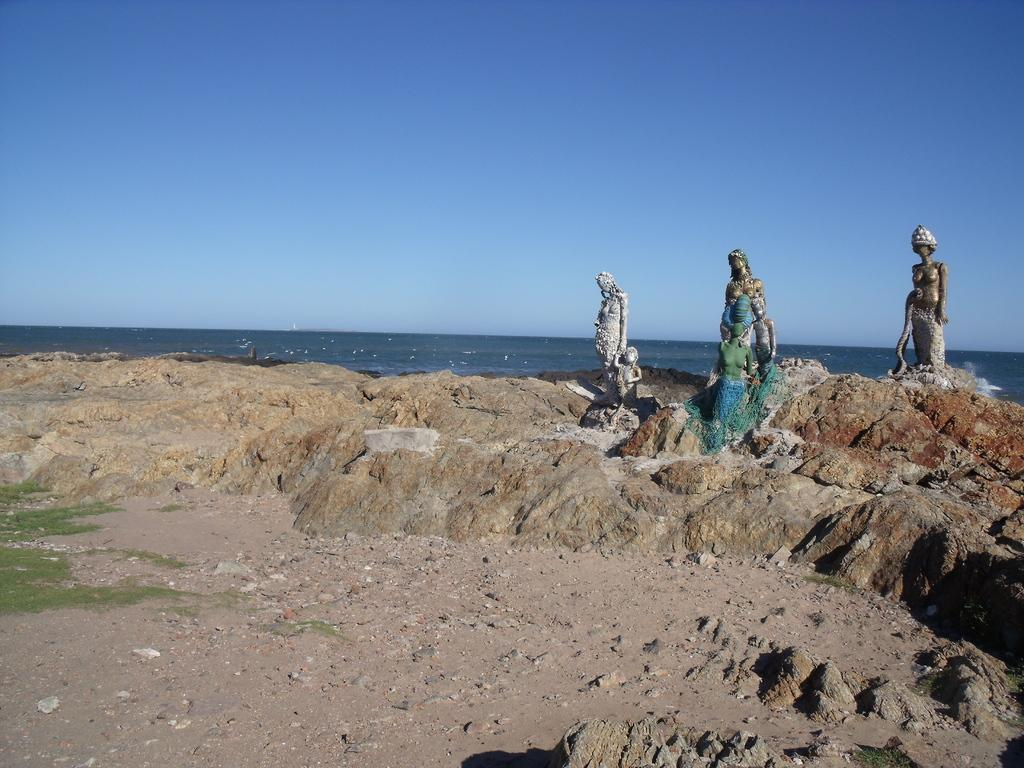What can be seen in the picture besides the sky? There are statues in the picture. What is the color of the sky in the picture? The sky is blue in the picture. Can you describe the water visible in the picture? There is water visible in the picture, but its characteristics are not mentioned in the facts. What type of cemetery can be seen in the picture? There is no cemetery present in the picture; it features statues and a blue sky. Can you tell me how many birds are flying in the picture? There is no mention of birds or flying in the picture, so it cannot be determined from the image. 